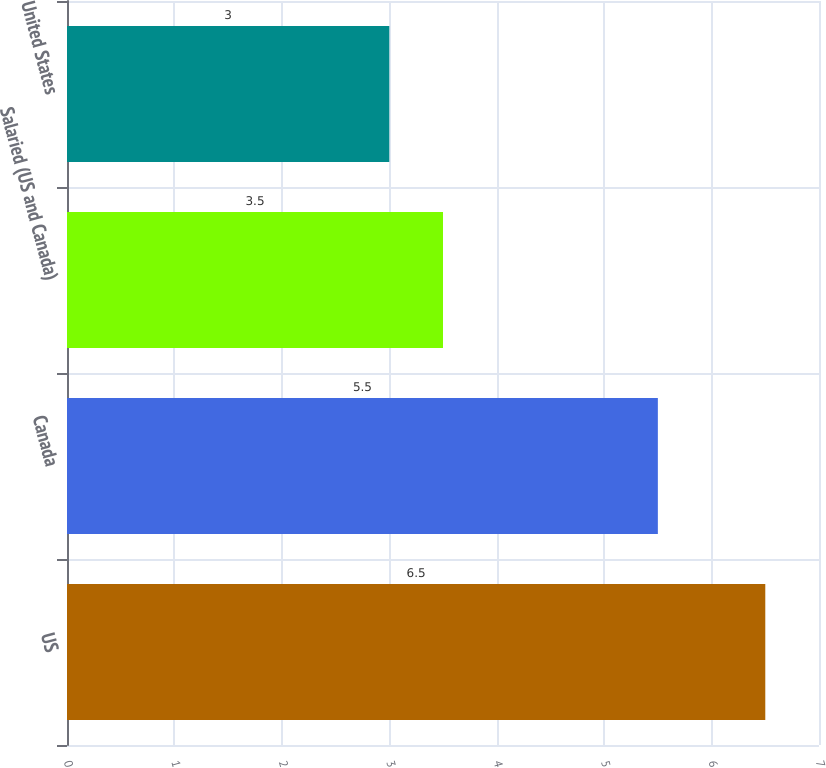Convert chart. <chart><loc_0><loc_0><loc_500><loc_500><bar_chart><fcel>US<fcel>Canada<fcel>Salaried (US and Canada)<fcel>United States<nl><fcel>6.5<fcel>5.5<fcel>3.5<fcel>3<nl></chart> 